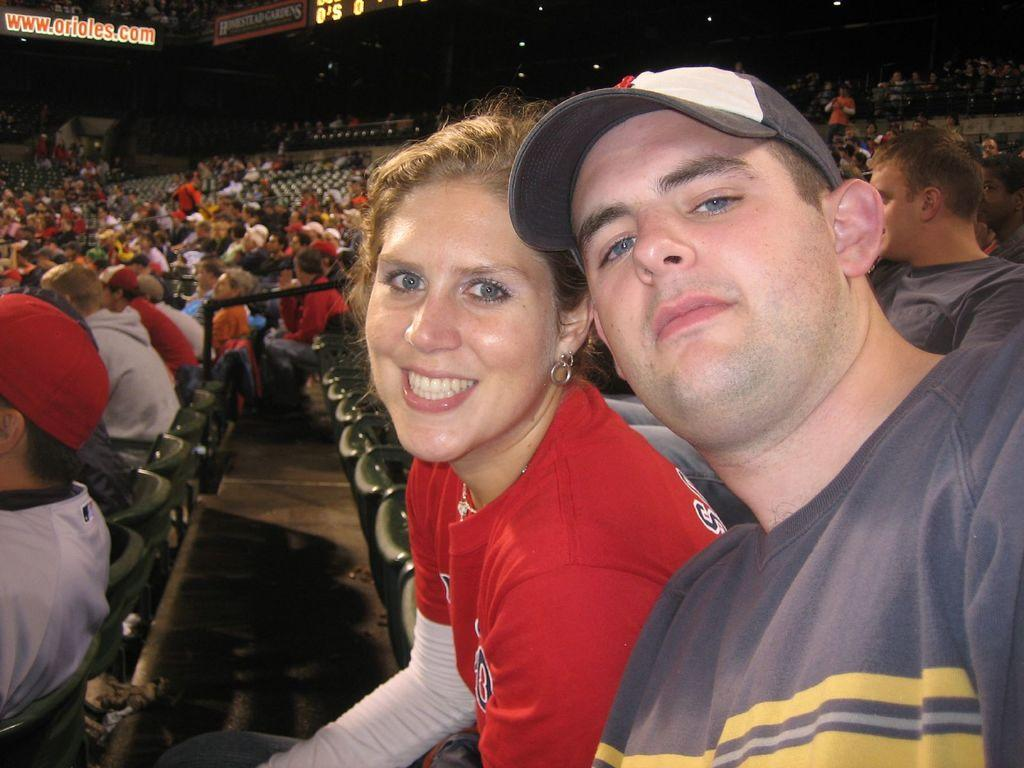How many people are present in the image? There are at least two people in the image, a guy and a girl. What are the guy and the girl doing in the image? Both the guy and the girl are sitting on chairs. Are there any other people in the image besides the guy and the girl? Yes, there are other people in the image. How many chairs are visible in the image? There are additional chairs in the image. What type of vase is placed on the tray in the image? There is no vase or tray present in the image. Can you describe the man sitting next to the girl in the image? There is no mention of a man in the image; only a guy and a girl are mentioned. 